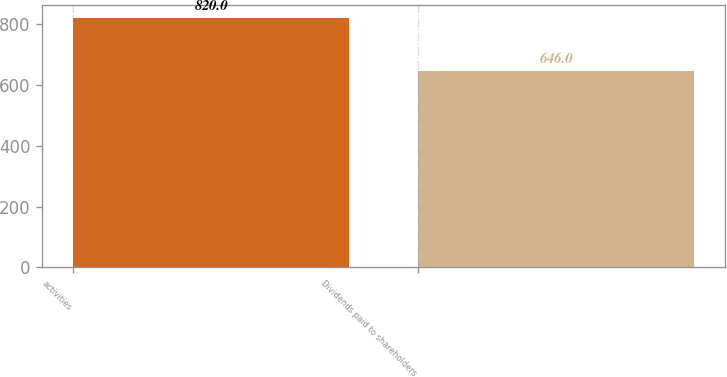Convert chart to OTSL. <chart><loc_0><loc_0><loc_500><loc_500><bar_chart><fcel>activities<fcel>Dividends paid to shareholders<nl><fcel>820<fcel>646<nl></chart> 